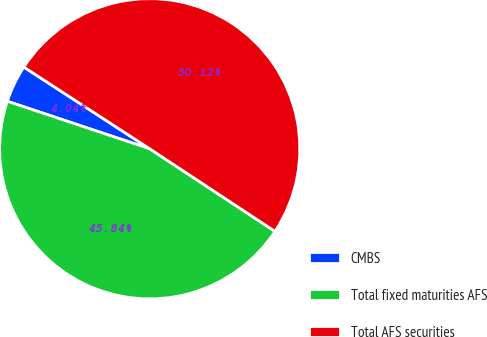<chart> <loc_0><loc_0><loc_500><loc_500><pie_chart><fcel>CMBS<fcel>Total fixed maturities AFS<fcel>Total AFS securities<nl><fcel>4.04%<fcel>45.84%<fcel>50.11%<nl></chart> 